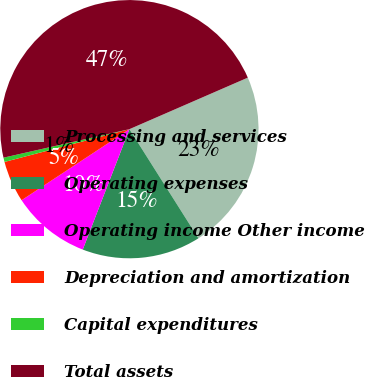<chart> <loc_0><loc_0><loc_500><loc_500><pie_chart><fcel>Processing and services<fcel>Operating expenses<fcel>Operating income Other income<fcel>Depreciation and amortization<fcel>Capital expenditures<fcel>Total assets<nl><fcel>22.56%<fcel>14.86%<fcel>9.84%<fcel>5.19%<fcel>0.54%<fcel>47.01%<nl></chart> 